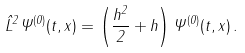Convert formula to latex. <formula><loc_0><loc_0><loc_500><loc_500>\hat { L } ^ { 2 } \Psi ^ { ( 0 ) } ( t , x ) = \left ( \frac { h ^ { 2 } } { 2 } + h \right ) \Psi ^ { ( 0 ) } ( t , x ) \, .</formula> 